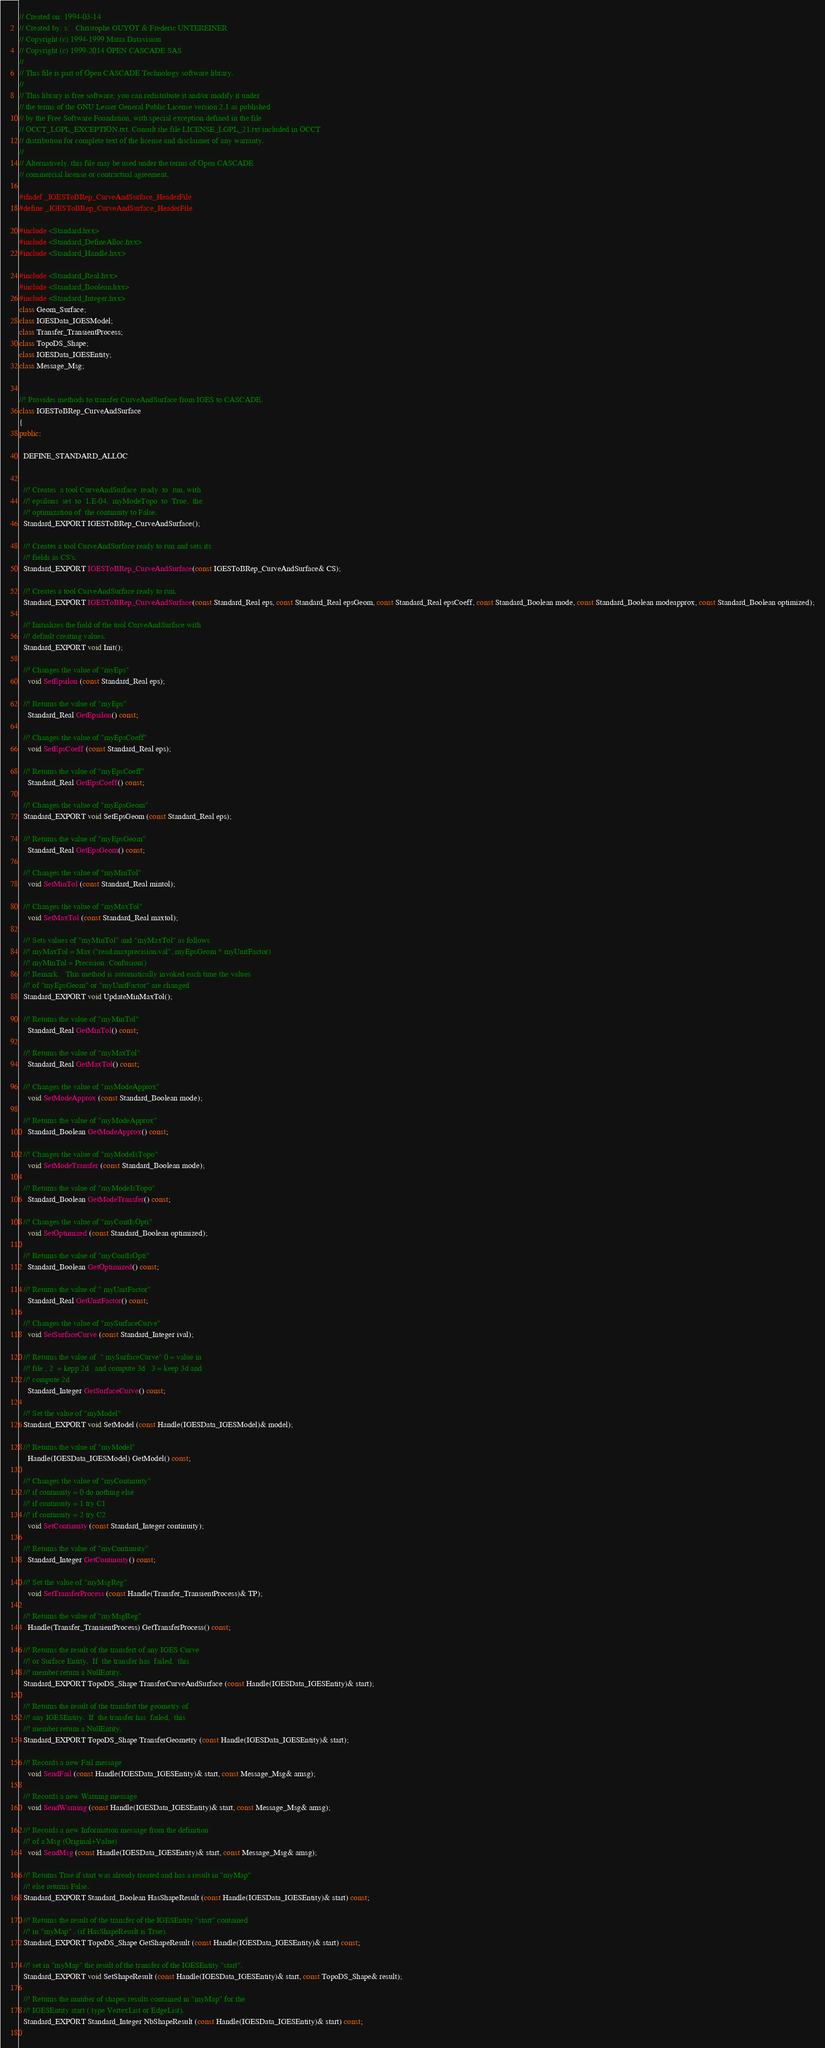Convert code to text. <code><loc_0><loc_0><loc_500><loc_500><_C++_>// Created on: 1994-03-14
// Created by: s:	Christophe GUYOT & Frederic UNTEREINER
// Copyright (c) 1994-1999 Matra Datavision
// Copyright (c) 1999-2014 OPEN CASCADE SAS
//
// This file is part of Open CASCADE Technology software library.
//
// This library is free software; you can redistribute it and/or modify it under
// the terms of the GNU Lesser General Public License version 2.1 as published
// by the Free Software Foundation, with special exception defined in the file
// OCCT_LGPL_EXCEPTION.txt. Consult the file LICENSE_LGPL_21.txt included in OCCT
// distribution for complete text of the license and disclaimer of any warranty.
//
// Alternatively, this file may be used under the terms of Open CASCADE
// commercial license or contractual agreement.

#ifndef _IGESToBRep_CurveAndSurface_HeaderFile
#define _IGESToBRep_CurveAndSurface_HeaderFile

#include <Standard.hxx>
#include <Standard_DefineAlloc.hxx>
#include <Standard_Handle.hxx>

#include <Standard_Real.hxx>
#include <Standard_Boolean.hxx>
#include <Standard_Integer.hxx>
class Geom_Surface;
class IGESData_IGESModel;
class Transfer_TransientProcess;
class TopoDS_Shape;
class IGESData_IGESEntity;
class Message_Msg;


//! Provides methods to transfer CurveAndSurface from IGES to CASCADE.
class IGESToBRep_CurveAndSurface 
{
public:

  DEFINE_STANDARD_ALLOC

  
  //! Creates  a tool CurveAndSurface  ready  to  run, with
  //! epsilons  set  to  1.E-04,  myModeTopo  to  True,  the
  //! optimization of  the continuity to False.
  Standard_EXPORT IGESToBRep_CurveAndSurface();
  
  //! Creates a tool CurveAndSurface ready to run and sets its
  //! fields as CS's.
  Standard_EXPORT IGESToBRep_CurveAndSurface(const IGESToBRep_CurveAndSurface& CS);
  
  //! Creates a tool CurveAndSurface ready to run.
  Standard_EXPORT IGESToBRep_CurveAndSurface(const Standard_Real eps, const Standard_Real epsGeom, const Standard_Real epsCoeff, const Standard_Boolean mode, const Standard_Boolean modeapprox, const Standard_Boolean optimized);
  
  //! Initializes the field of the tool CurveAndSurface with
  //! default creating values.
  Standard_EXPORT void Init();
  
  //! Changes the value of "myEps"
    void SetEpsilon (const Standard_Real eps);
  
  //! Returns the value of "myEps"
    Standard_Real GetEpsilon() const;
  
  //! Changes the value of "myEpsCoeff"
    void SetEpsCoeff (const Standard_Real eps);
  
  //! Returns the value of "myEpsCoeff"
    Standard_Real GetEpsCoeff() const;
  
  //! Changes the value of "myEpsGeom"
  Standard_EXPORT void SetEpsGeom (const Standard_Real eps);
  
  //! Returns the value of "myEpsGeom"
    Standard_Real GetEpsGeom() const;
  
  //! Changes the value of "myMinTol"
    void SetMinTol (const Standard_Real mintol);
  
  //! Changes the value of "myMaxTol"
    void SetMaxTol (const Standard_Real maxtol);
  
  //! Sets values of "myMinTol" and "myMaxTol" as follows
  //! myMaxTol = Max ("read.maxprecision.val", myEpsGeom * myUnitFactor)
  //! myMinTol = Precision::Confusion()
  //! Remark:   This method is automatically invoked each time the values
  //! of "myEpsGeom" or "myUnitFactor" are changed
  Standard_EXPORT void UpdateMinMaxTol();
  
  //! Returns the value of "myMinTol"
    Standard_Real GetMinTol() const;
  
  //! Returns the value of "myMaxTol"
    Standard_Real GetMaxTol() const;
  
  //! Changes the value of "myModeApprox"
    void SetModeApprox (const Standard_Boolean mode);
  
  //! Returns the value of "myModeApprox"
    Standard_Boolean GetModeApprox() const;
  
  //! Changes the value of "myModeIsTopo"
    void SetModeTransfer (const Standard_Boolean mode);
  
  //! Returns the value of "myModeIsTopo"
    Standard_Boolean GetModeTransfer() const;
  
  //! Changes the value of "myContIsOpti"
    void SetOptimized (const Standard_Boolean optimized);
  
  //! Returns the value of "myContIsOpti"
    Standard_Boolean GetOptimized() const;
  
  //! Returns the value of " myUnitFactor"
    Standard_Real GetUnitFactor() const;
  
  //! Changes the value of "mySurfaceCurve"
    void SetSurfaceCurve (const Standard_Integer ival);
  
  //! Returns the value of  " mySurfaceCurve" 0 = value in
  //! file , 2  = kepp 2d   and compute 3d   3 = keep 3d and
  //! compute 2d
    Standard_Integer GetSurfaceCurve() const;
  
  //! Set the value of "myModel"
  Standard_EXPORT void SetModel (const Handle(IGESData_IGESModel)& model);
  
  //! Returns the value of "myModel"
    Handle(IGESData_IGESModel) GetModel() const;
  
  //! Changes the value of "myContinuity"
  //! if continuity = 0 do nothing else
  //! if continuity = 1 try C1
  //! if continuity = 2 try C2
    void SetContinuity (const Standard_Integer continuity);
  
  //! Returns the value of "myContinuity"
    Standard_Integer GetContinuity() const;
  
  //! Set the value of "myMsgReg"
    void SetTransferProcess (const Handle(Transfer_TransientProcess)& TP);
  
  //! Returns the value of "myMsgReg"
    Handle(Transfer_TransientProcess) GetTransferProcess() const;
  
  //! Returns the result of the transfert of any IGES Curve
  //! or Surface Entity.  If  the transfer has  failed,  this
  //! member return a NullEntity.
  Standard_EXPORT TopoDS_Shape TransferCurveAndSurface (const Handle(IGESData_IGESEntity)& start);
  
  //! Returns the result of the transfert the geometry of
  //! any IGESEntity.  If  the transfer has  failed,  this
  //! member return a NullEntity.
  Standard_EXPORT TopoDS_Shape TransferGeometry (const Handle(IGESData_IGESEntity)& start);
  
  //! Records a new Fail message
    void SendFail (const Handle(IGESData_IGESEntity)& start, const Message_Msg& amsg);
  
  //! Records a new Warning message
    void SendWarning (const Handle(IGESData_IGESEntity)& start, const Message_Msg& amsg);
  
  //! Records a new Information message from the definition
  //! of a Msg (Original+Value)
    void SendMsg (const Handle(IGESData_IGESEntity)& start, const Message_Msg& amsg);
  
  //! Returns True if start was already treated and has a result in "myMap"
  //! else returns False.
  Standard_EXPORT Standard_Boolean HasShapeResult (const Handle(IGESData_IGESEntity)& start) const;
  
  //! Returns the result of the transfer of the IGESEntity "start" contained
  //! in "myMap" . (if HasShapeResult is True).
  Standard_EXPORT TopoDS_Shape GetShapeResult (const Handle(IGESData_IGESEntity)& start) const;
  
  //! set in "myMap" the result of the transfer of the IGESEntity "start".
  Standard_EXPORT void SetShapeResult (const Handle(IGESData_IGESEntity)& start, const TopoDS_Shape& result);
  
  //! Returns the number of shapes results contained in "myMap" for the
  //! IGESEntity start ( type VertexList or EdgeList).
  Standard_EXPORT Standard_Integer NbShapeResult (const Handle(IGESData_IGESEntity)& start) const;
  </code> 